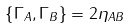Convert formula to latex. <formula><loc_0><loc_0><loc_500><loc_500>\left \{ \Gamma _ { A } , \Gamma _ { B } \right \} = 2 \eta _ { A B }</formula> 